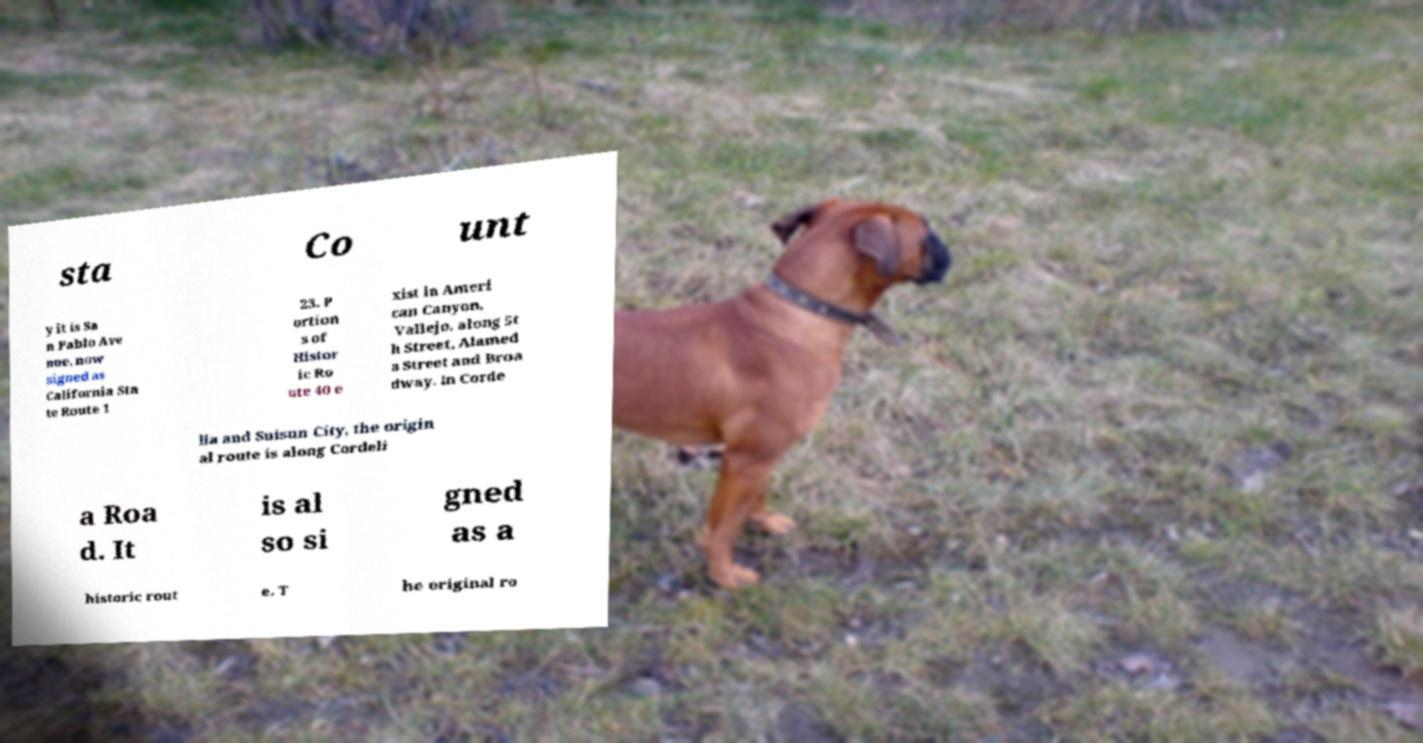Could you assist in decoding the text presented in this image and type it out clearly? sta Co unt y it is Sa n Pablo Ave nue, now signed as California Sta te Route 1 23. P ortion s of Histor ic Ro ute 40 e xist in Ameri can Canyon, Vallejo, along 5t h Street, Alamed a Street and Broa dway. In Corde lia and Suisun City, the origin al route is along Cordeli a Roa d. It is al so si gned as a historic rout e. T he original ro 